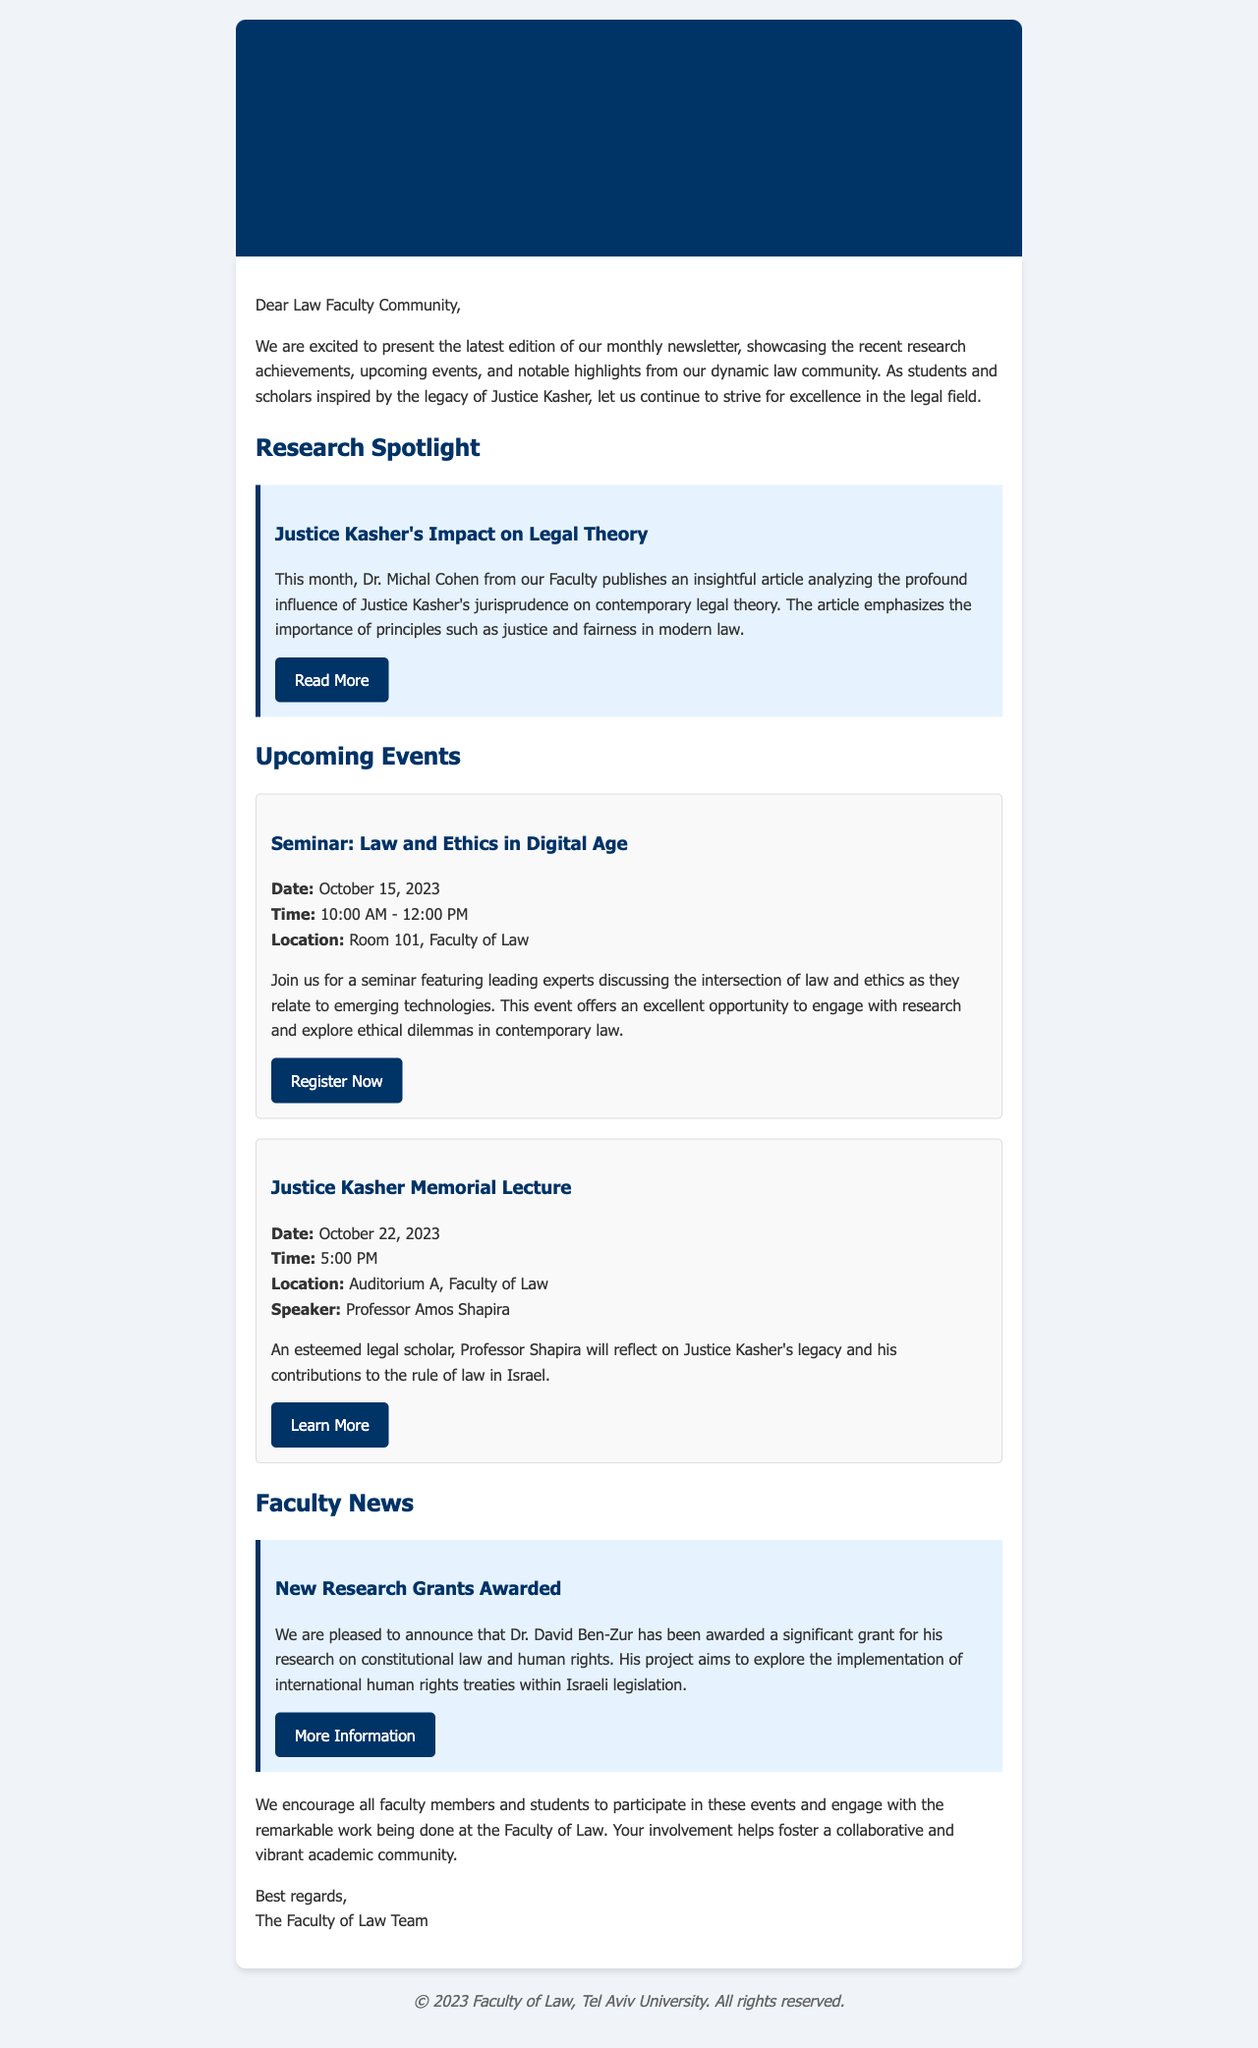what is the title of the newsletter? The title of the newsletter is stated clearly at the top of the document.
Answer: Monthly Newsletter who published the research article on Justice Kasher's influence? The author of the research article is mentioned in the research section.
Answer: Dr. Michal Cohen when is the Justice Kasher Memorial Lecture scheduled? The date of the lecture is provided in the upcoming events section.
Answer: October 22, 2023 what is the main topic of the seminar on October 15, 2023? The topic of the seminar is described in the event details.
Answer: Law and Ethics in Digital Age who will speak at the Justice Kasher Memorial Lecture? The speaker for the lecture is specified in the event details.
Answer: Professor Amos Shapira what significant grant was awarded to Dr. David Ben-Zur for? The purpose of Dr. Ben-Zur's research grant is outlined in the faculty news.
Answer: Constitutional law and human rights which department's research achievements are highlighted in the newsletter? The newsletter focuses on the achievements of a specific academic unit mentioned at the start.
Answer: Faculty of Law what is the time duration of the seminar on October 15, 2023? The duration of the seminar is given in the event details.
Answer: 10:00 AM - 12:00 PM 